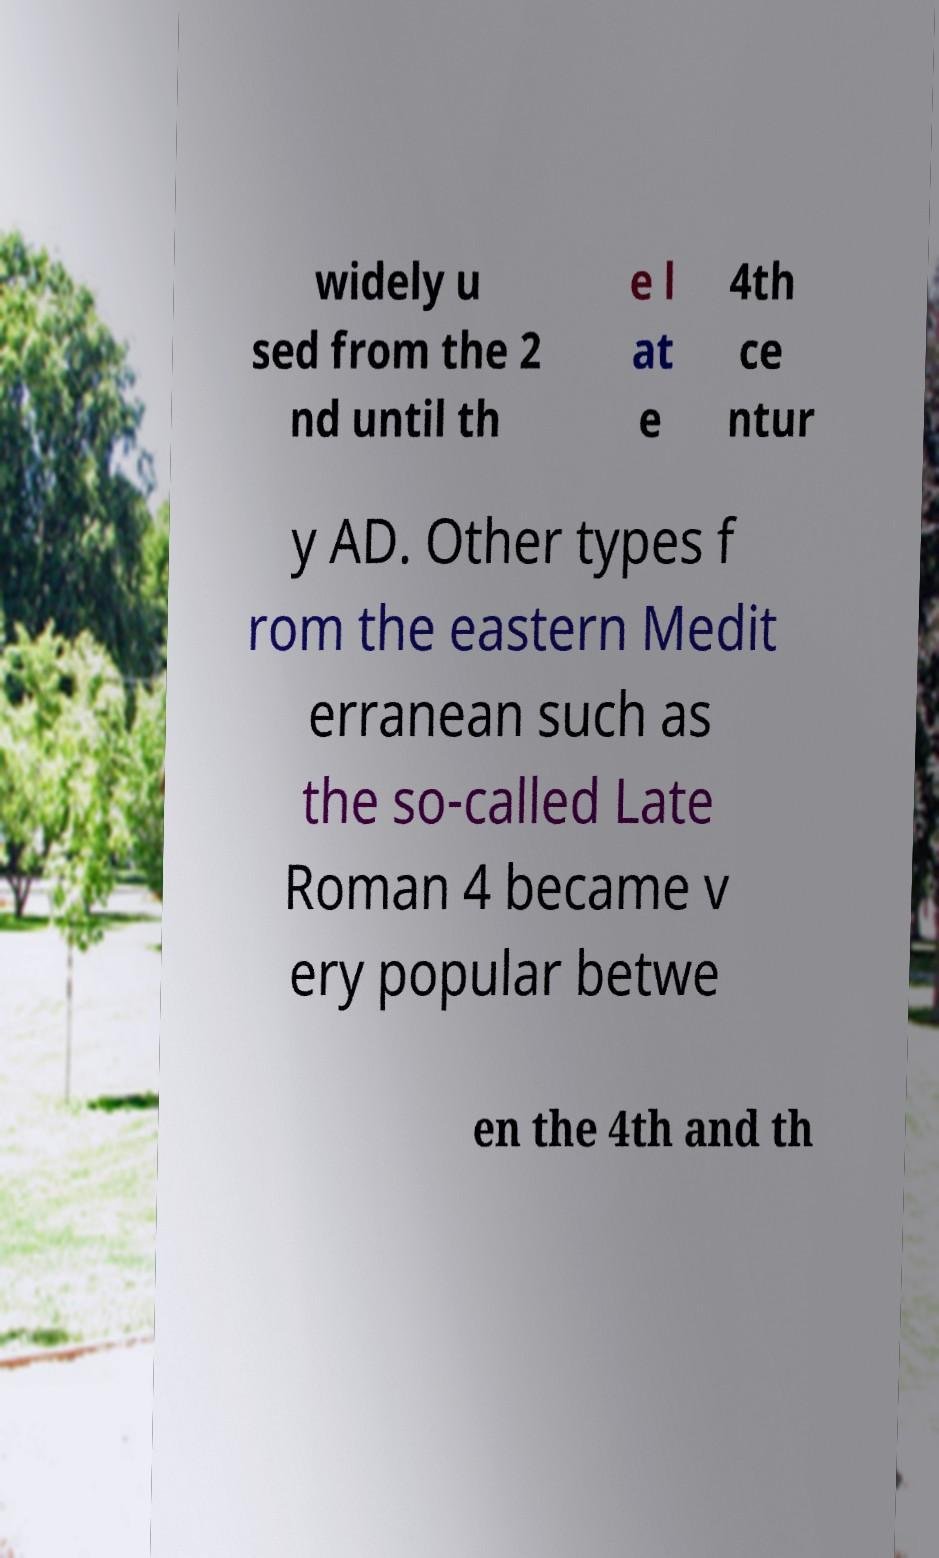Can you accurately transcribe the text from the provided image for me? widely u sed from the 2 nd until th e l at e 4th ce ntur y AD. Other types f rom the eastern Medit erranean such as the so-called Late Roman 4 became v ery popular betwe en the 4th and th 